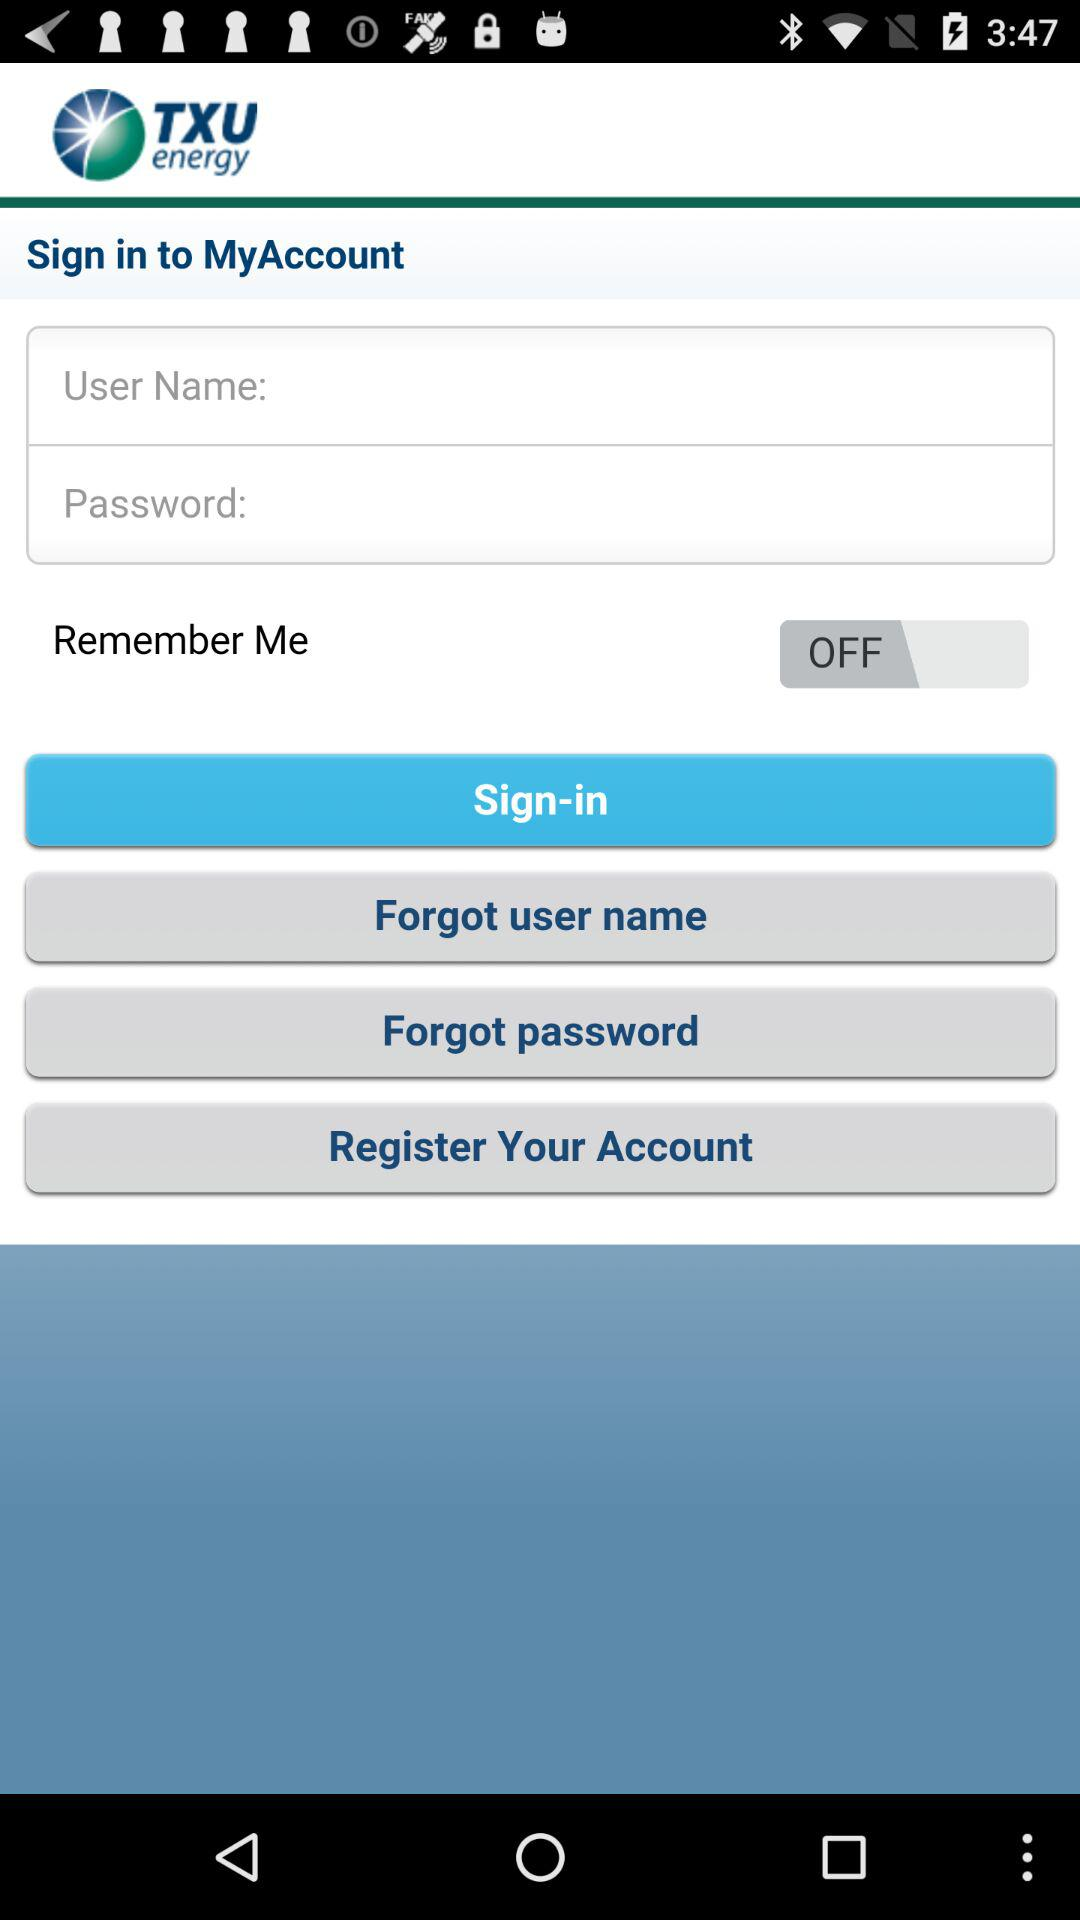Can we reset password?
When the provided information is insufficient, respond with <no answer>. <no answer> 